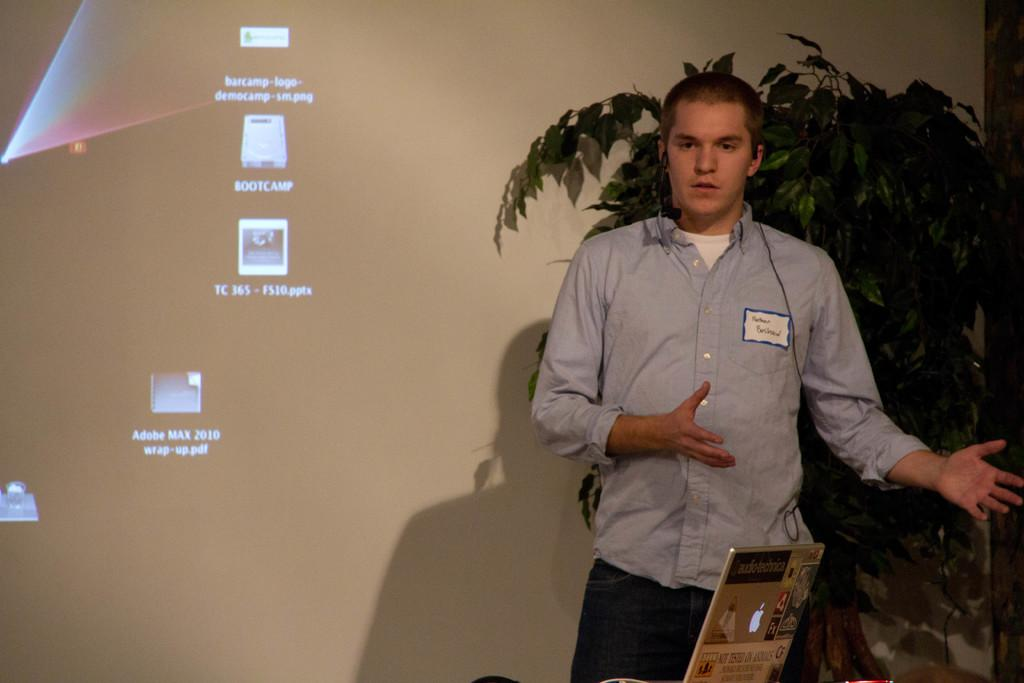What is the man in the image doing? The facts provided do not specify what the man is doing, only that he is standing. What color is the shirt the man is wearing? The man is wearing a blue shirt. What can be seen in the background of the image? There is a plant in the background of the image. What object is on the table in the image? There is a laptop on a table in the image. What is visible on the laptop screen? The facts provided do not specify what is visible on the laptop screen. How many buckets of water are being used to water the garden in the image? There is no garden or buckets of water present in the image. 